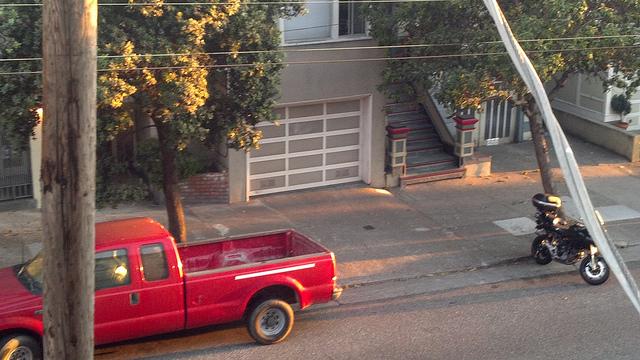What color is the truck?
Quick response, please. Red. What color is the motorcycle?
Answer briefly. Black. Where is the truck parked?
Keep it brief. On street. 